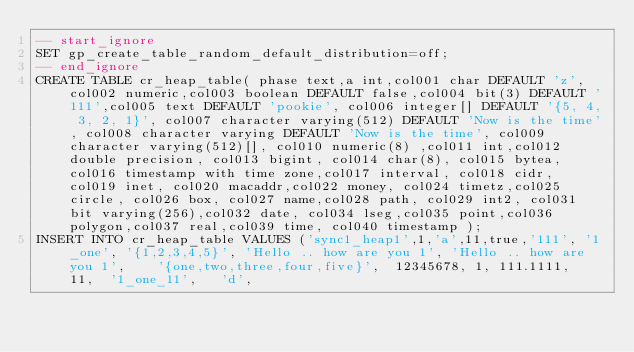<code> <loc_0><loc_0><loc_500><loc_500><_SQL_>-- start_ignore
SET gp_create_table_random_default_distribution=off;
-- end_ignore
CREATE TABLE cr_heap_table( phase text,a int,col001 char DEFAULT 'z',col002 numeric,col003 boolean DEFAULT false,col004 bit(3) DEFAULT '111',col005 text DEFAULT 'pookie', col006 integer[] DEFAULT '{5, 4, 3, 2, 1}', col007 character varying(512) DEFAULT 'Now is the time', col008 character varying DEFAULT 'Now is the time', col009 character varying(512)[], col010 numeric(8) ,col011 int,col012 double precision, col013 bigint, col014 char(8), col015 bytea,col016 timestamp with time zone,col017 interval, col018 cidr, col019 inet, col020 macaddr,col022 money, col024 timetz,col025 circle, col026 box, col027 name,col028 path, col029 int2, col031 bit varying(256),col032 date, col034 lseg,col035 point,col036 polygon,col037 real,col039 time, col040 timestamp );
INSERT INTO cr_heap_table VALUES ('sync1_heap1',1,'a',11,true,'111', '1_one', '{1,2,3,4,5}', 'Hello .. how are you 1', 'Hello .. how are you 1',    '{one,two,three,four,five}',  12345678, 1, 111.1111,  11,  '1_one_11',   'd',  </code> 